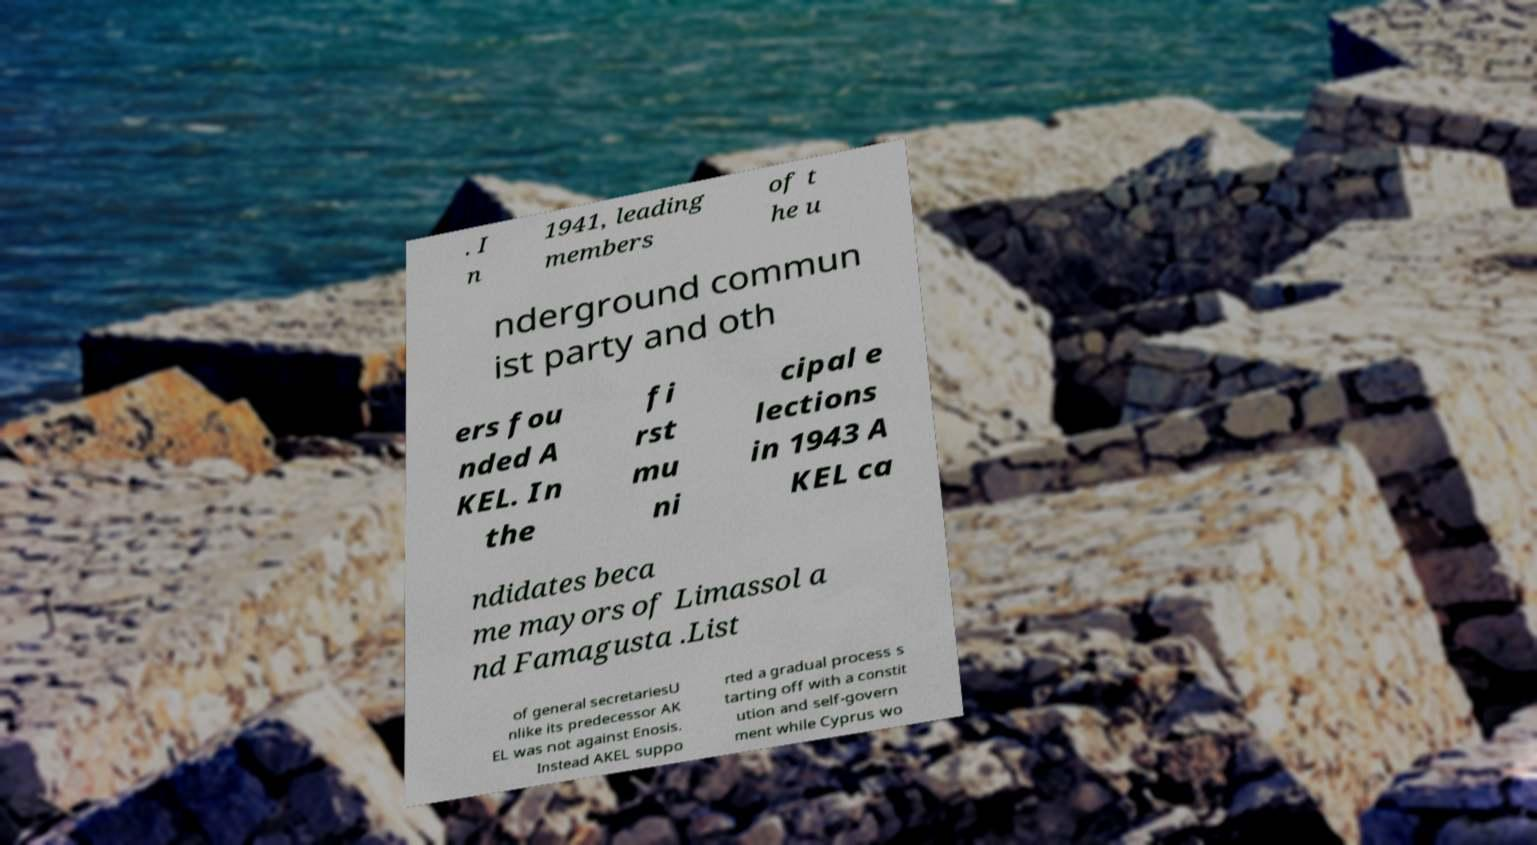For documentation purposes, I need the text within this image transcribed. Could you provide that? . I n 1941, leading members of t he u nderground commun ist party and oth ers fou nded A KEL. In the fi rst mu ni cipal e lections in 1943 A KEL ca ndidates beca me mayors of Limassol a nd Famagusta .List of general secretariesU nlike its predecessor AK EL was not against Enosis. Instead AKEL suppo rted a gradual process s tarting off with a constit ution and self-govern ment while Cyprus wo 